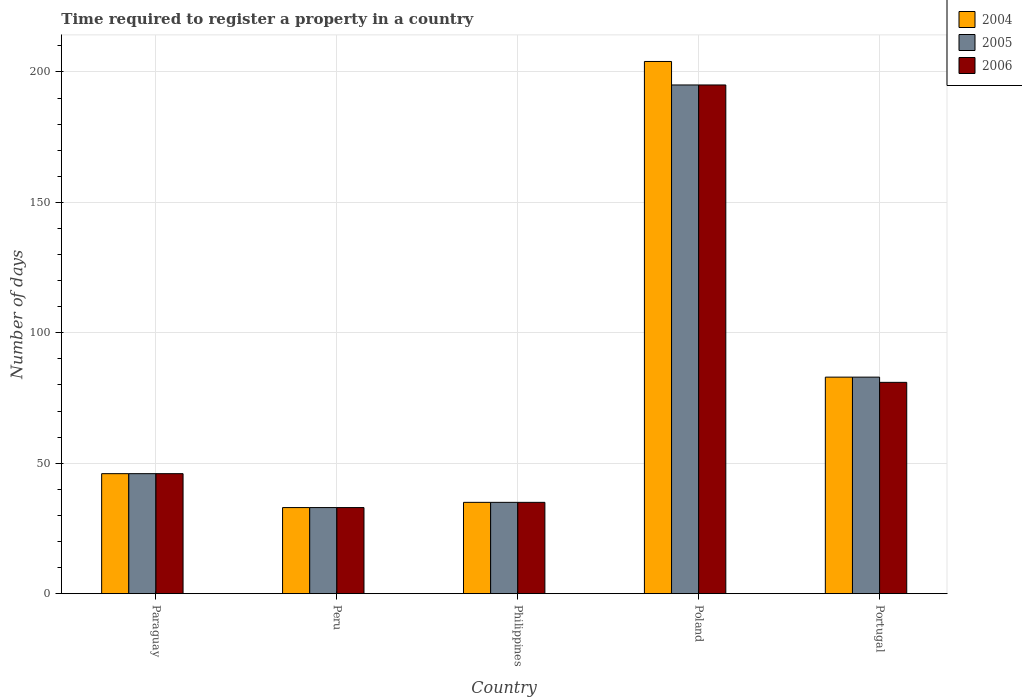How many groups of bars are there?
Provide a succinct answer. 5. How many bars are there on the 5th tick from the right?
Provide a succinct answer. 3. In how many cases, is the number of bars for a given country not equal to the number of legend labels?
Provide a succinct answer. 0. What is the number of days required to register a property in 2006 in Paraguay?
Make the answer very short. 46. Across all countries, what is the maximum number of days required to register a property in 2005?
Provide a short and direct response. 195. In which country was the number of days required to register a property in 2006 maximum?
Ensure brevity in your answer.  Poland. What is the total number of days required to register a property in 2005 in the graph?
Give a very brief answer. 392. What is the difference between the number of days required to register a property in 2005 in Paraguay and that in Portugal?
Your answer should be compact. -37. What is the difference between the number of days required to register a property in 2006 in Poland and the number of days required to register a property in 2004 in Philippines?
Give a very brief answer. 160. What is the average number of days required to register a property in 2005 per country?
Your answer should be very brief. 78.4. In how many countries, is the number of days required to register a property in 2005 greater than 120 days?
Provide a succinct answer. 1. What is the ratio of the number of days required to register a property in 2004 in Philippines to that in Poland?
Provide a short and direct response. 0.17. Is the number of days required to register a property in 2006 in Peru less than that in Philippines?
Give a very brief answer. Yes. What is the difference between the highest and the second highest number of days required to register a property in 2005?
Your answer should be compact. -112. What is the difference between the highest and the lowest number of days required to register a property in 2005?
Your response must be concise. 162. Is the sum of the number of days required to register a property in 2006 in Paraguay and Peru greater than the maximum number of days required to register a property in 2004 across all countries?
Make the answer very short. No. What does the 1st bar from the left in Portugal represents?
Provide a short and direct response. 2004. What does the 1st bar from the right in Poland represents?
Make the answer very short. 2006. Is it the case that in every country, the sum of the number of days required to register a property in 2005 and number of days required to register a property in 2006 is greater than the number of days required to register a property in 2004?
Give a very brief answer. Yes. How many bars are there?
Give a very brief answer. 15. What is the difference between two consecutive major ticks on the Y-axis?
Make the answer very short. 50. Are the values on the major ticks of Y-axis written in scientific E-notation?
Your answer should be very brief. No. Where does the legend appear in the graph?
Ensure brevity in your answer.  Top right. How are the legend labels stacked?
Ensure brevity in your answer.  Vertical. What is the title of the graph?
Give a very brief answer. Time required to register a property in a country. Does "1962" appear as one of the legend labels in the graph?
Your answer should be very brief. No. What is the label or title of the Y-axis?
Offer a very short reply. Number of days. What is the Number of days in 2006 in Paraguay?
Give a very brief answer. 46. What is the Number of days in 2004 in Philippines?
Ensure brevity in your answer.  35. What is the Number of days of 2005 in Philippines?
Give a very brief answer. 35. What is the Number of days of 2004 in Poland?
Make the answer very short. 204. What is the Number of days in 2005 in Poland?
Make the answer very short. 195. What is the Number of days of 2006 in Poland?
Offer a terse response. 195. What is the Number of days in 2004 in Portugal?
Your answer should be compact. 83. What is the Number of days in 2005 in Portugal?
Offer a terse response. 83. Across all countries, what is the maximum Number of days in 2004?
Ensure brevity in your answer.  204. Across all countries, what is the maximum Number of days of 2005?
Provide a short and direct response. 195. Across all countries, what is the maximum Number of days of 2006?
Keep it short and to the point. 195. Across all countries, what is the minimum Number of days in 2006?
Offer a terse response. 33. What is the total Number of days in 2004 in the graph?
Provide a short and direct response. 401. What is the total Number of days of 2005 in the graph?
Ensure brevity in your answer.  392. What is the total Number of days of 2006 in the graph?
Give a very brief answer. 390. What is the difference between the Number of days in 2004 in Paraguay and that in Peru?
Your answer should be very brief. 13. What is the difference between the Number of days in 2004 in Paraguay and that in Philippines?
Offer a terse response. 11. What is the difference between the Number of days of 2006 in Paraguay and that in Philippines?
Keep it short and to the point. 11. What is the difference between the Number of days of 2004 in Paraguay and that in Poland?
Provide a succinct answer. -158. What is the difference between the Number of days in 2005 in Paraguay and that in Poland?
Your answer should be very brief. -149. What is the difference between the Number of days in 2006 in Paraguay and that in Poland?
Provide a succinct answer. -149. What is the difference between the Number of days in 2004 in Paraguay and that in Portugal?
Make the answer very short. -37. What is the difference between the Number of days of 2005 in Paraguay and that in Portugal?
Offer a very short reply. -37. What is the difference between the Number of days of 2006 in Paraguay and that in Portugal?
Your response must be concise. -35. What is the difference between the Number of days of 2006 in Peru and that in Philippines?
Your response must be concise. -2. What is the difference between the Number of days of 2004 in Peru and that in Poland?
Your answer should be compact. -171. What is the difference between the Number of days in 2005 in Peru and that in Poland?
Your response must be concise. -162. What is the difference between the Number of days of 2006 in Peru and that in Poland?
Provide a short and direct response. -162. What is the difference between the Number of days in 2004 in Peru and that in Portugal?
Give a very brief answer. -50. What is the difference between the Number of days in 2005 in Peru and that in Portugal?
Make the answer very short. -50. What is the difference between the Number of days of 2006 in Peru and that in Portugal?
Provide a short and direct response. -48. What is the difference between the Number of days of 2004 in Philippines and that in Poland?
Provide a short and direct response. -169. What is the difference between the Number of days in 2005 in Philippines and that in Poland?
Keep it short and to the point. -160. What is the difference between the Number of days in 2006 in Philippines and that in Poland?
Your answer should be compact. -160. What is the difference between the Number of days in 2004 in Philippines and that in Portugal?
Offer a very short reply. -48. What is the difference between the Number of days in 2005 in Philippines and that in Portugal?
Ensure brevity in your answer.  -48. What is the difference between the Number of days in 2006 in Philippines and that in Portugal?
Ensure brevity in your answer.  -46. What is the difference between the Number of days of 2004 in Poland and that in Portugal?
Give a very brief answer. 121. What is the difference between the Number of days in 2005 in Poland and that in Portugal?
Ensure brevity in your answer.  112. What is the difference between the Number of days in 2006 in Poland and that in Portugal?
Your response must be concise. 114. What is the difference between the Number of days in 2005 in Paraguay and the Number of days in 2006 in Peru?
Your response must be concise. 13. What is the difference between the Number of days of 2005 in Paraguay and the Number of days of 2006 in Philippines?
Keep it short and to the point. 11. What is the difference between the Number of days of 2004 in Paraguay and the Number of days of 2005 in Poland?
Offer a terse response. -149. What is the difference between the Number of days in 2004 in Paraguay and the Number of days in 2006 in Poland?
Provide a short and direct response. -149. What is the difference between the Number of days in 2005 in Paraguay and the Number of days in 2006 in Poland?
Keep it short and to the point. -149. What is the difference between the Number of days of 2004 in Paraguay and the Number of days of 2005 in Portugal?
Provide a short and direct response. -37. What is the difference between the Number of days of 2004 in Paraguay and the Number of days of 2006 in Portugal?
Your answer should be compact. -35. What is the difference between the Number of days of 2005 in Paraguay and the Number of days of 2006 in Portugal?
Provide a short and direct response. -35. What is the difference between the Number of days in 2004 in Peru and the Number of days in 2005 in Poland?
Give a very brief answer. -162. What is the difference between the Number of days of 2004 in Peru and the Number of days of 2006 in Poland?
Offer a very short reply. -162. What is the difference between the Number of days of 2005 in Peru and the Number of days of 2006 in Poland?
Offer a terse response. -162. What is the difference between the Number of days of 2004 in Peru and the Number of days of 2006 in Portugal?
Your response must be concise. -48. What is the difference between the Number of days in 2005 in Peru and the Number of days in 2006 in Portugal?
Your answer should be compact. -48. What is the difference between the Number of days in 2004 in Philippines and the Number of days in 2005 in Poland?
Make the answer very short. -160. What is the difference between the Number of days of 2004 in Philippines and the Number of days of 2006 in Poland?
Provide a short and direct response. -160. What is the difference between the Number of days of 2005 in Philippines and the Number of days of 2006 in Poland?
Give a very brief answer. -160. What is the difference between the Number of days in 2004 in Philippines and the Number of days in 2005 in Portugal?
Make the answer very short. -48. What is the difference between the Number of days of 2004 in Philippines and the Number of days of 2006 in Portugal?
Your response must be concise. -46. What is the difference between the Number of days in 2005 in Philippines and the Number of days in 2006 in Portugal?
Provide a short and direct response. -46. What is the difference between the Number of days of 2004 in Poland and the Number of days of 2005 in Portugal?
Offer a very short reply. 121. What is the difference between the Number of days of 2004 in Poland and the Number of days of 2006 in Portugal?
Ensure brevity in your answer.  123. What is the difference between the Number of days in 2005 in Poland and the Number of days in 2006 in Portugal?
Provide a succinct answer. 114. What is the average Number of days in 2004 per country?
Make the answer very short. 80.2. What is the average Number of days in 2005 per country?
Make the answer very short. 78.4. What is the average Number of days in 2006 per country?
Provide a short and direct response. 78. What is the difference between the Number of days in 2005 and Number of days in 2006 in Paraguay?
Keep it short and to the point. 0. What is the difference between the Number of days in 2004 and Number of days in 2005 in Peru?
Offer a terse response. 0. What is the difference between the Number of days of 2005 and Number of days of 2006 in Peru?
Give a very brief answer. 0. What is the difference between the Number of days in 2004 and Number of days in 2005 in Philippines?
Offer a very short reply. 0. What is the difference between the Number of days in 2004 and Number of days in 2006 in Philippines?
Your answer should be compact. 0. What is the difference between the Number of days in 2005 and Number of days in 2006 in Philippines?
Provide a succinct answer. 0. What is the difference between the Number of days of 2005 and Number of days of 2006 in Poland?
Offer a very short reply. 0. What is the difference between the Number of days in 2005 and Number of days in 2006 in Portugal?
Ensure brevity in your answer.  2. What is the ratio of the Number of days of 2004 in Paraguay to that in Peru?
Give a very brief answer. 1.39. What is the ratio of the Number of days in 2005 in Paraguay to that in Peru?
Your answer should be very brief. 1.39. What is the ratio of the Number of days in 2006 in Paraguay to that in Peru?
Make the answer very short. 1.39. What is the ratio of the Number of days of 2004 in Paraguay to that in Philippines?
Your response must be concise. 1.31. What is the ratio of the Number of days in 2005 in Paraguay to that in Philippines?
Your answer should be very brief. 1.31. What is the ratio of the Number of days of 2006 in Paraguay to that in Philippines?
Offer a terse response. 1.31. What is the ratio of the Number of days of 2004 in Paraguay to that in Poland?
Ensure brevity in your answer.  0.23. What is the ratio of the Number of days of 2005 in Paraguay to that in Poland?
Provide a succinct answer. 0.24. What is the ratio of the Number of days in 2006 in Paraguay to that in Poland?
Provide a succinct answer. 0.24. What is the ratio of the Number of days in 2004 in Paraguay to that in Portugal?
Offer a terse response. 0.55. What is the ratio of the Number of days of 2005 in Paraguay to that in Portugal?
Provide a succinct answer. 0.55. What is the ratio of the Number of days in 2006 in Paraguay to that in Portugal?
Your answer should be compact. 0.57. What is the ratio of the Number of days in 2004 in Peru to that in Philippines?
Your answer should be compact. 0.94. What is the ratio of the Number of days of 2005 in Peru to that in Philippines?
Give a very brief answer. 0.94. What is the ratio of the Number of days in 2006 in Peru to that in Philippines?
Give a very brief answer. 0.94. What is the ratio of the Number of days in 2004 in Peru to that in Poland?
Provide a short and direct response. 0.16. What is the ratio of the Number of days of 2005 in Peru to that in Poland?
Your answer should be compact. 0.17. What is the ratio of the Number of days of 2006 in Peru to that in Poland?
Ensure brevity in your answer.  0.17. What is the ratio of the Number of days in 2004 in Peru to that in Portugal?
Offer a terse response. 0.4. What is the ratio of the Number of days of 2005 in Peru to that in Portugal?
Your response must be concise. 0.4. What is the ratio of the Number of days of 2006 in Peru to that in Portugal?
Your answer should be very brief. 0.41. What is the ratio of the Number of days of 2004 in Philippines to that in Poland?
Provide a short and direct response. 0.17. What is the ratio of the Number of days in 2005 in Philippines to that in Poland?
Make the answer very short. 0.18. What is the ratio of the Number of days of 2006 in Philippines to that in Poland?
Keep it short and to the point. 0.18. What is the ratio of the Number of days of 2004 in Philippines to that in Portugal?
Give a very brief answer. 0.42. What is the ratio of the Number of days of 2005 in Philippines to that in Portugal?
Offer a terse response. 0.42. What is the ratio of the Number of days of 2006 in Philippines to that in Portugal?
Your response must be concise. 0.43. What is the ratio of the Number of days of 2004 in Poland to that in Portugal?
Offer a terse response. 2.46. What is the ratio of the Number of days of 2005 in Poland to that in Portugal?
Provide a succinct answer. 2.35. What is the ratio of the Number of days of 2006 in Poland to that in Portugal?
Your answer should be compact. 2.41. What is the difference between the highest and the second highest Number of days of 2004?
Offer a terse response. 121. What is the difference between the highest and the second highest Number of days in 2005?
Provide a succinct answer. 112. What is the difference between the highest and the second highest Number of days in 2006?
Provide a short and direct response. 114. What is the difference between the highest and the lowest Number of days in 2004?
Keep it short and to the point. 171. What is the difference between the highest and the lowest Number of days in 2005?
Provide a short and direct response. 162. What is the difference between the highest and the lowest Number of days in 2006?
Your answer should be very brief. 162. 